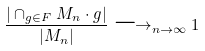Convert formula to latex. <formula><loc_0><loc_0><loc_500><loc_500>\frac { | \cap _ { g \in F } M _ { n } \cdot g | } { | M _ { n } | } \longrightarrow _ { n \to \infty } 1</formula> 